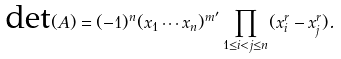Convert formula to latex. <formula><loc_0><loc_0><loc_500><loc_500>\text {det} ( A ) = ( - 1 ) ^ { n } ( x _ { 1 } \cdots x _ { n } ) ^ { m ^ { \prime } } \prod _ { 1 \leq i < j \leq n } ( x _ { i } ^ { r } - x _ { j } ^ { r } ) .</formula> 